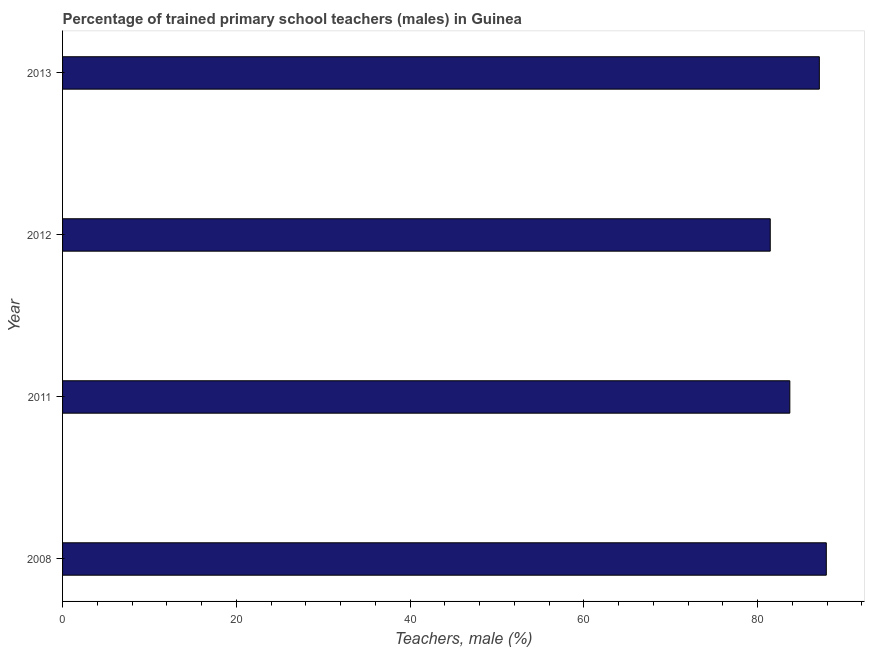Does the graph contain grids?
Provide a short and direct response. No. What is the title of the graph?
Your answer should be very brief. Percentage of trained primary school teachers (males) in Guinea. What is the label or title of the X-axis?
Provide a succinct answer. Teachers, male (%). What is the label or title of the Y-axis?
Make the answer very short. Year. What is the percentage of trained male teachers in 2012?
Provide a short and direct response. 81.45. Across all years, what is the maximum percentage of trained male teachers?
Offer a very short reply. 87.9. Across all years, what is the minimum percentage of trained male teachers?
Provide a short and direct response. 81.45. In which year was the percentage of trained male teachers minimum?
Your response must be concise. 2012. What is the sum of the percentage of trained male teachers?
Provide a succinct answer. 340.13. What is the difference between the percentage of trained male teachers in 2008 and 2012?
Keep it short and to the point. 6.45. What is the average percentage of trained male teachers per year?
Make the answer very short. 85.03. What is the median percentage of trained male teachers?
Provide a short and direct response. 85.4. In how many years, is the percentage of trained male teachers greater than 64 %?
Provide a succinct answer. 4. Do a majority of the years between 2011 and 2013 (inclusive) have percentage of trained male teachers greater than 32 %?
Your answer should be very brief. Yes. Is the difference between the percentage of trained male teachers in 2011 and 2013 greater than the difference between any two years?
Offer a terse response. No. What is the difference between the highest and the second highest percentage of trained male teachers?
Your answer should be very brief. 0.8. Is the sum of the percentage of trained male teachers in 2008 and 2012 greater than the maximum percentage of trained male teachers across all years?
Provide a short and direct response. Yes. What is the difference between the highest and the lowest percentage of trained male teachers?
Your answer should be very brief. 6.45. In how many years, is the percentage of trained male teachers greater than the average percentage of trained male teachers taken over all years?
Provide a short and direct response. 2. How many bars are there?
Provide a short and direct response. 4. Are all the bars in the graph horizontal?
Make the answer very short. Yes. Are the values on the major ticks of X-axis written in scientific E-notation?
Ensure brevity in your answer.  No. What is the Teachers, male (%) in 2008?
Offer a terse response. 87.9. What is the Teachers, male (%) in 2011?
Provide a short and direct response. 83.7. What is the Teachers, male (%) of 2012?
Keep it short and to the point. 81.45. What is the Teachers, male (%) of 2013?
Provide a succinct answer. 87.09. What is the difference between the Teachers, male (%) in 2008 and 2011?
Your answer should be compact. 4.2. What is the difference between the Teachers, male (%) in 2008 and 2012?
Make the answer very short. 6.45. What is the difference between the Teachers, male (%) in 2008 and 2013?
Provide a short and direct response. 0.8. What is the difference between the Teachers, male (%) in 2011 and 2012?
Make the answer very short. 2.25. What is the difference between the Teachers, male (%) in 2011 and 2013?
Your answer should be compact. -3.4. What is the difference between the Teachers, male (%) in 2012 and 2013?
Ensure brevity in your answer.  -5.65. What is the ratio of the Teachers, male (%) in 2008 to that in 2011?
Provide a succinct answer. 1.05. What is the ratio of the Teachers, male (%) in 2008 to that in 2012?
Ensure brevity in your answer.  1.08. What is the ratio of the Teachers, male (%) in 2011 to that in 2012?
Give a very brief answer. 1.03. What is the ratio of the Teachers, male (%) in 2011 to that in 2013?
Ensure brevity in your answer.  0.96. What is the ratio of the Teachers, male (%) in 2012 to that in 2013?
Give a very brief answer. 0.94. 